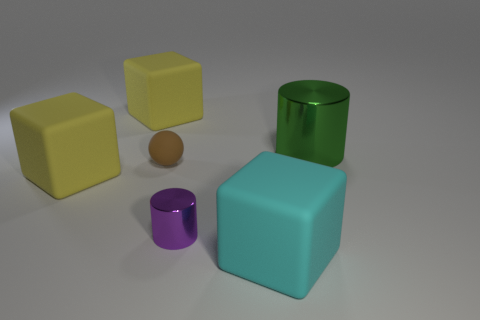What is the shape of the large green object?
Your response must be concise. Cylinder. What is the material of the big yellow object that is in front of the large cylinder in front of the matte object behind the green object?
Give a very brief answer. Rubber. What number of cyan things are either small matte things or big metallic cylinders?
Your answer should be compact. 0. What is the size of the shiny thing that is in front of the shiny cylinder behind the yellow matte object in front of the large green object?
Make the answer very short. Small. The green object that is the same shape as the purple object is what size?
Your response must be concise. Large. What number of small things are red matte blocks or cubes?
Offer a terse response. 0. Is the cylinder that is behind the tiny purple shiny object made of the same material as the block that is behind the large green thing?
Offer a terse response. No. What is the material of the cylinder that is to the left of the cyan thing?
Your answer should be very brief. Metal. How many rubber things are either blue cubes or yellow things?
Offer a very short reply. 2. What is the color of the cube that is to the right of the metallic cylinder to the left of the green cylinder?
Provide a short and direct response. Cyan. 